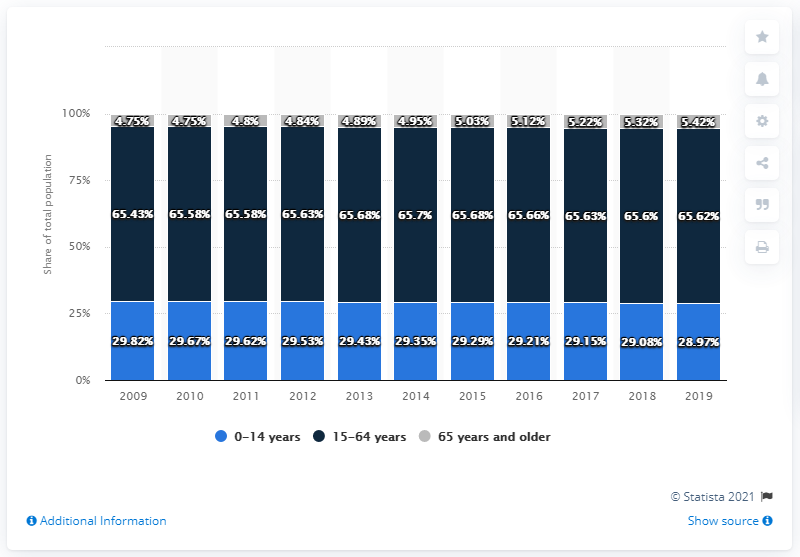Outline some significant characteristics in this image. In the year 2009, there were the most number of 0-14 year-olds. The age structure of the highest and lowest age between 0-14 is 58.79%. 